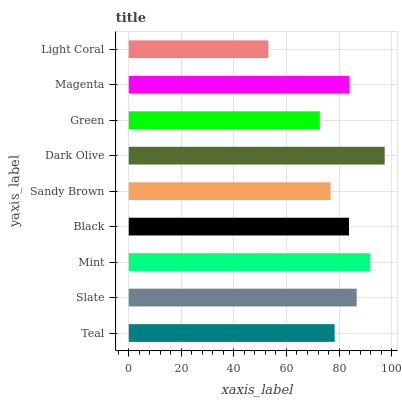Is Light Coral the minimum?
Answer yes or no. Yes. Is Dark Olive the maximum?
Answer yes or no. Yes. Is Slate the minimum?
Answer yes or no. No. Is Slate the maximum?
Answer yes or no. No. Is Slate greater than Teal?
Answer yes or no. Yes. Is Teal less than Slate?
Answer yes or no. Yes. Is Teal greater than Slate?
Answer yes or no. No. Is Slate less than Teal?
Answer yes or no. No. Is Black the high median?
Answer yes or no. Yes. Is Black the low median?
Answer yes or no. Yes. Is Mint the high median?
Answer yes or no. No. Is Green the low median?
Answer yes or no. No. 